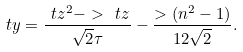<formula> <loc_0><loc_0><loc_500><loc_500>\ t y = \frac { \ t z ^ { 2 } - > \ t z } { \sqrt { 2 } \tau } - \frac { > ( n ^ { 2 } - 1 ) } { 1 2 \sqrt { 2 } } .</formula> 